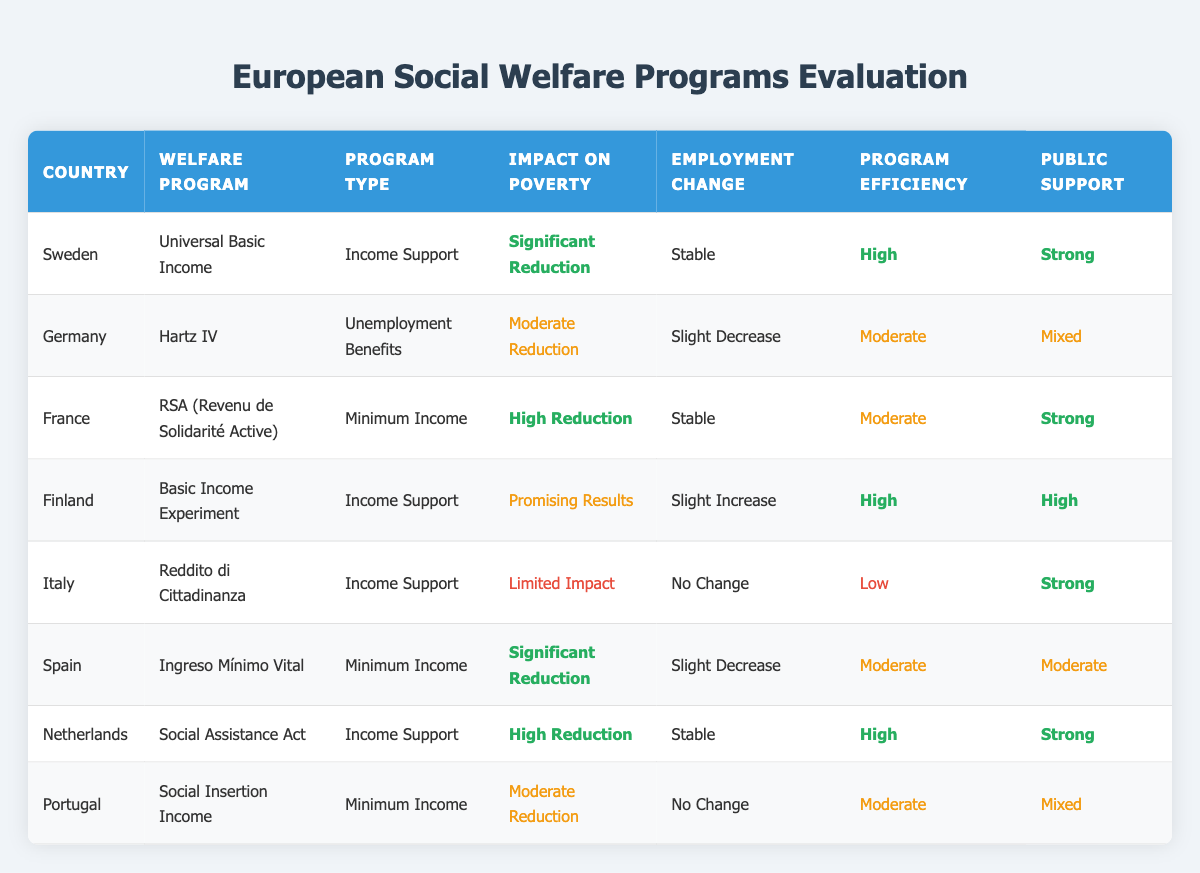What impact on poverty does Sweden's Universal Basic Income program have? The table indicates that Sweden's Universal Basic Income program has a "Significant Reduction" impact on poverty. This information is directly listed in the "Impact on Poverty" column corresponding to Sweden's row.
Answer: Significant Reduction Which country has the highest program efficiency? The highest program efficiency is represented by "High". In the table, both Sweden and Finland have this classification. Therefore, two countries share the highest program efficiency.
Answer: Sweden, Finland Does Italy's Reddito di Cittadinanza program have a high impact on poverty reduction? According to the table, Italy's Reddito di Cittadinanza is classified as having "Limited Impact" on poverty reduction. This confirms that the program does not have a high impact.
Answer: No What are the public support ratings for Spain's Ingreso Mínimo Vital? The public support for Spain's Ingreso Mínimo Vital is listed as "Moderate" in the table. This information is clearly shown in the "Public Support" column for Spain's row.
Answer: Moderate How many programs have a "High" impact on poverty reduction? Looking through the table, the programs with "High" impact on poverty are Sweden's Universal Basic Income, France's RSA, and Netherlands' Social Assistance Act. Counting these gives a total of three programs.
Answer: 3 Is there a country with both "High" impact on poverty and "Low" program efficiency? The table lists Sweden, France, and the Netherlands as having "High" impact on poverty, but Italy is the only country that shows "Low" program efficiency. Therefore, there is no country that has both characteristics.
Answer: No Which country's welfare program had a slight increase in employment? The table indicates that Finland's Basic Income Experiment led to a "Slight Increase" in employment, shown in its corresponding row under "Employment Change".
Answer: Finland What is the average public support level of the countries with moderate efficiency? The countries listed under moderate efficiency are Germany, Portugal, and Spain. Their respective public support ratings are "Mixed", "Mixed", and "Moderate". In a qualitative assessment, these represent a general moderate public support level. Thus, overall, the average public support can be considered "Moderate".
Answer: Moderate 